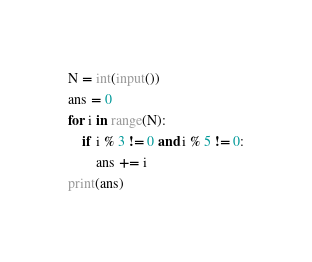Convert code to text. <code><loc_0><loc_0><loc_500><loc_500><_Python_>N = int(input())
ans = 0
for i in range(N):
    if i % 3 != 0 and i % 5 != 0:
        ans += i
print(ans)</code> 